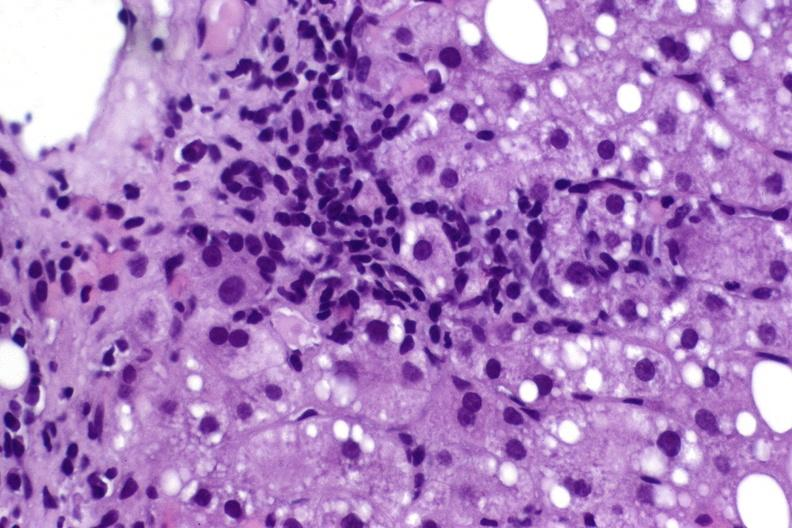s malignant histiocytosis present?
Answer the question using a single word or phrase. No 